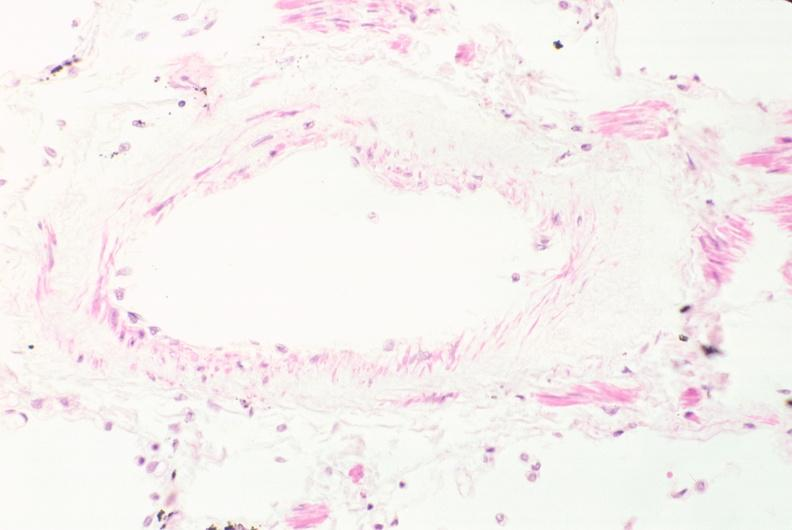where is this?
Answer the question using a single word or phrase. Lung 